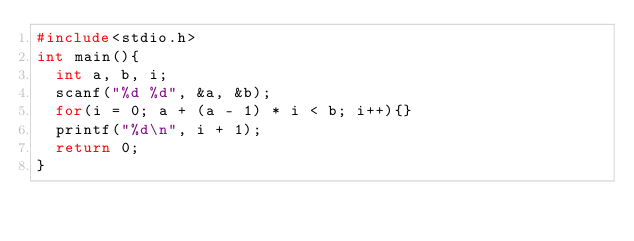Convert code to text. <code><loc_0><loc_0><loc_500><loc_500><_C_>#include<stdio.h>
int main(){
  int a, b, i;
  scanf("%d %d", &a, &b);
  for(i = 0; a + (a - 1) * i < b; i++){} 
  printf("%d\n", i + 1);
  return 0;
}</code> 